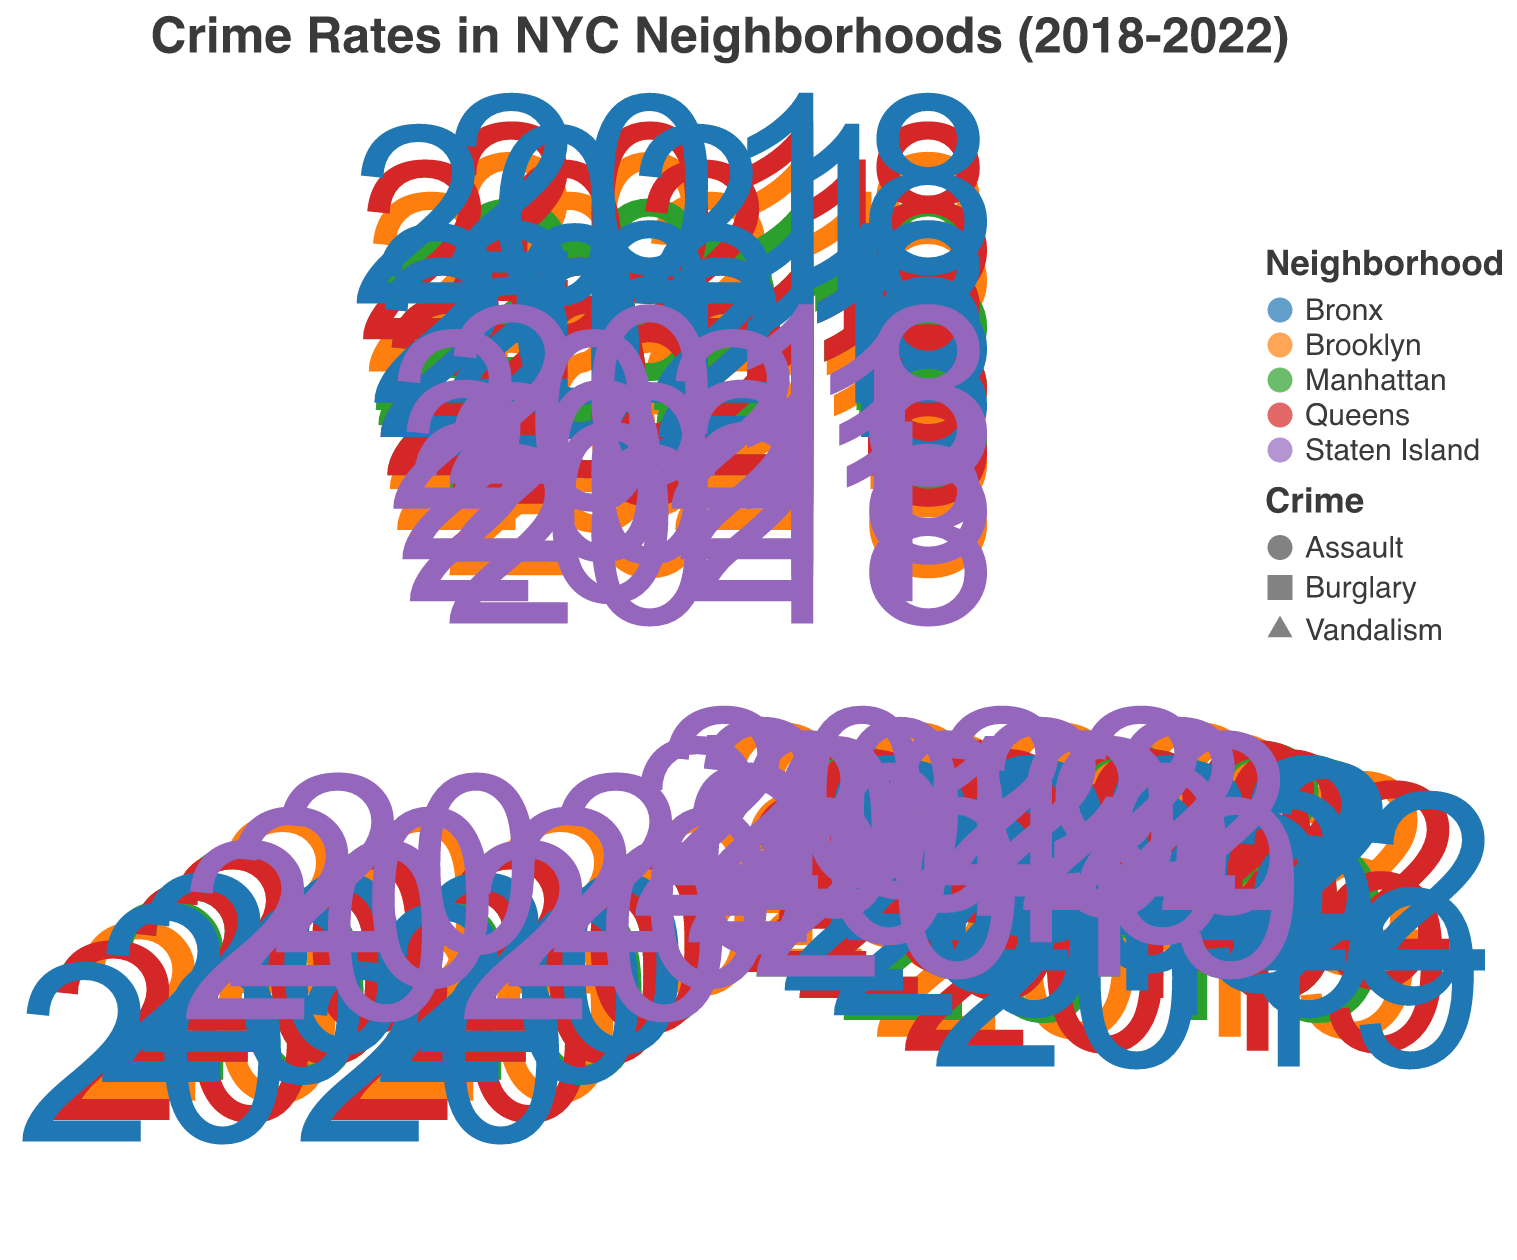What is the title of the figure? The title is usually located at the top of the chart. In this case, it is mentioned in the provided code as "Crime Rates in NYC Neighborhoods (2018-2022)".
Answer: "Crime Rates in NYC Neighborhoods (2018-2022)" Which neighborhood has the highest burglary rate in 2022? Look for the maximum radius for the "Burglary" marker in the year 2022. The Bronx has the highest burglary rate with a value of 400.
Answer: Bronx What is the overall trend in burglary rates in Brooklyn from 2018 to 2022? Observe the changes in the radius of the "circle" markers for Brooklyn over the years. There is a general decreasing trend in burglary rates from 2018 (350) to 2022 (290).
Answer: Decreasing Which type of crime had the highest count in Manhattan in 2021? Compare the radii of all shapes in Manhattan in 2021. The "circle" representing "Burglary" has a lower count (245) compared to "triangle" for "Assault" (225). Therefore, the "triangle" has the highest value.
Answer: Assault How does the trend of vandalism rates in Staten Island compare between 2019 and 2022? Compare the radius of the "square" markers for Staten Island between 2019 (85) and 2022 (80). The count remains relatively stable with a slight decrease.
Answer: Slight Decrease What is the difference in assault counts between the Bronx and Queens in 2022? Locate the "triangle" markers for both neighborhoods in 2022. The count for the Bronx is 215 and for Queens is 155. The difference is 215 - 155 = 60.
Answer: 60 Identify which neighborhood had the greatest reduction in vandalism from 2018 to 2022. Compare the changes in the "square" markers' radii across all neighborhoods from 2018 to 2022. The greatest reduction was seen in the Bronx, decreasing from 250 to 240.
Answer: Bronx What pattern can be observed about the burglary rates across all neighborhoods between 2018 and 2022? Examine the changes in the "circle" markers across all neighborhoods over the years. There is a general decreasing trend in burglary rates in all neighborhoods.
Answer: Decreasing Which crime type sees the most significant variation in rates in Queens between 2018 and 2022? Compare all three types of crimes in Queens over the years by examining the changes in the shapes (circle for burglary, square for vandalism, and triangle for assault). Vandalism shows noticeable fluctuations, peaking at 220 in 2020 and then decreasing to 190 in 2022.
Answer: Vandalism How do assault rates in Brooklyn compare from 2018 to 2022? Examine the radii of the "triangle" markers for Brooklyn across the years. The assault rates saw a growing trend, starting at 70 in 2018 and increasing to 95 in 2022.
Answer: Increasing 